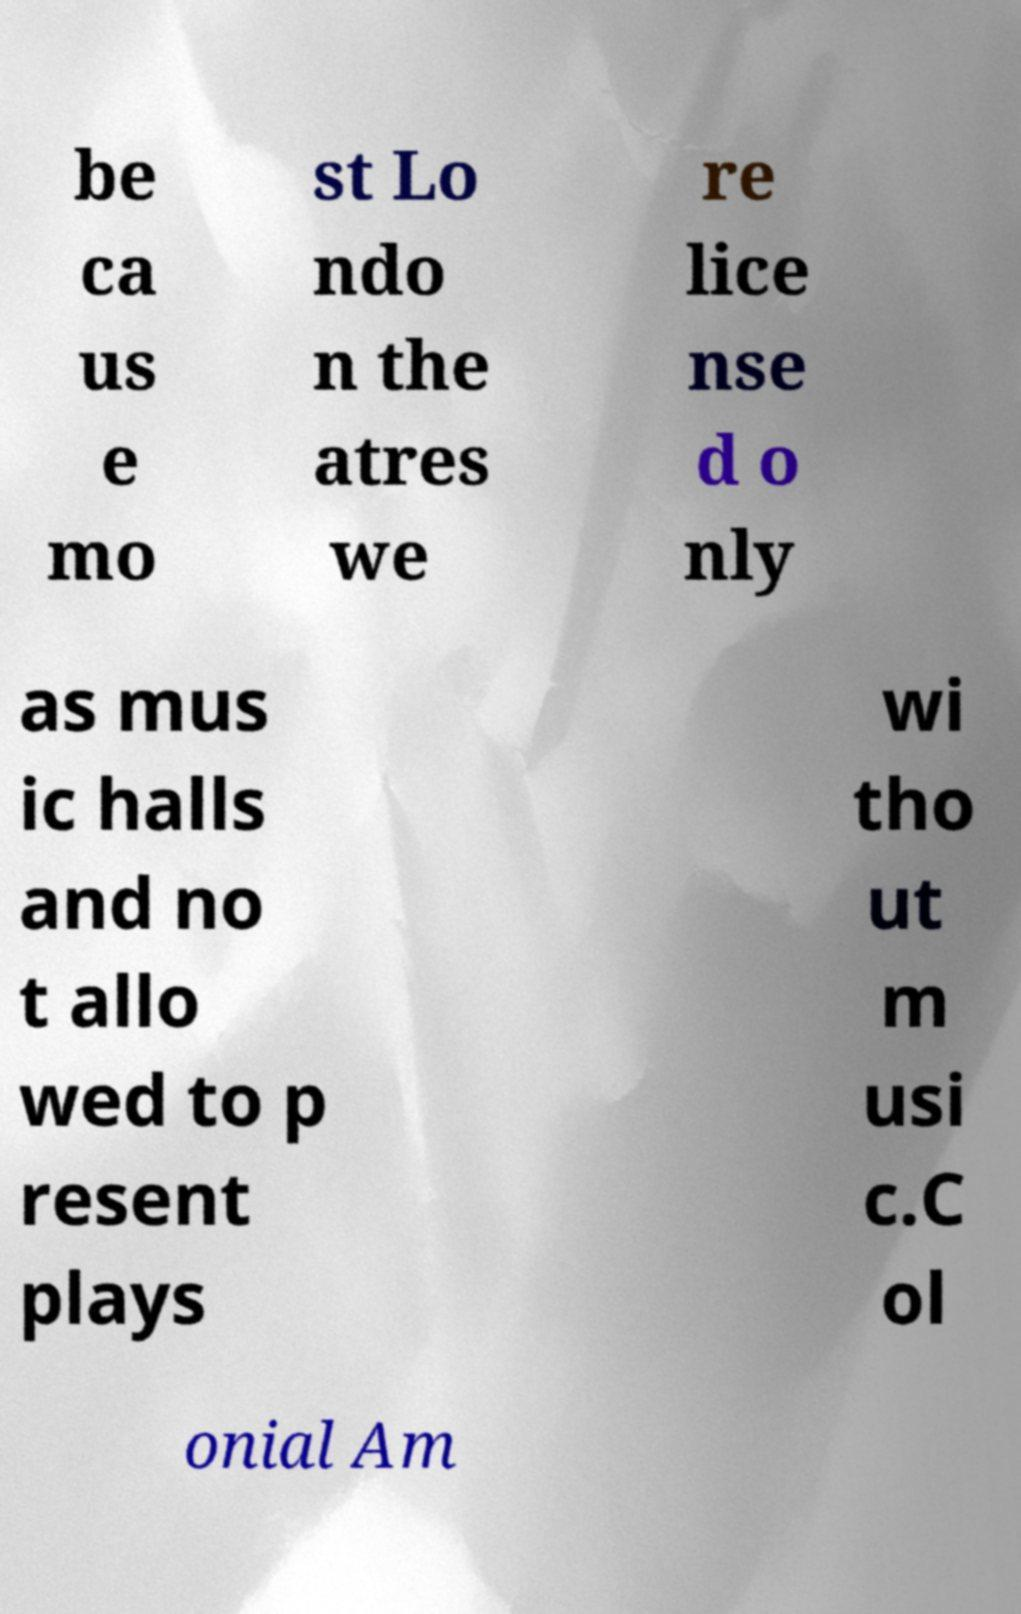Could you assist in decoding the text presented in this image and type it out clearly? be ca us e mo st Lo ndo n the atres we re lice nse d o nly as mus ic halls and no t allo wed to p resent plays wi tho ut m usi c.C ol onial Am 